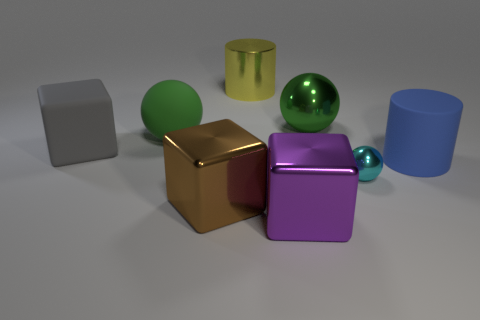Is there any indication of a light source in the scene? Yes, there are indications of a light source based on the shadows and highlights on the objects. The shadows are consistently cast to the lower right of the objects, suggesting a light source located to the top left of the scene, likely out of the image frame. 